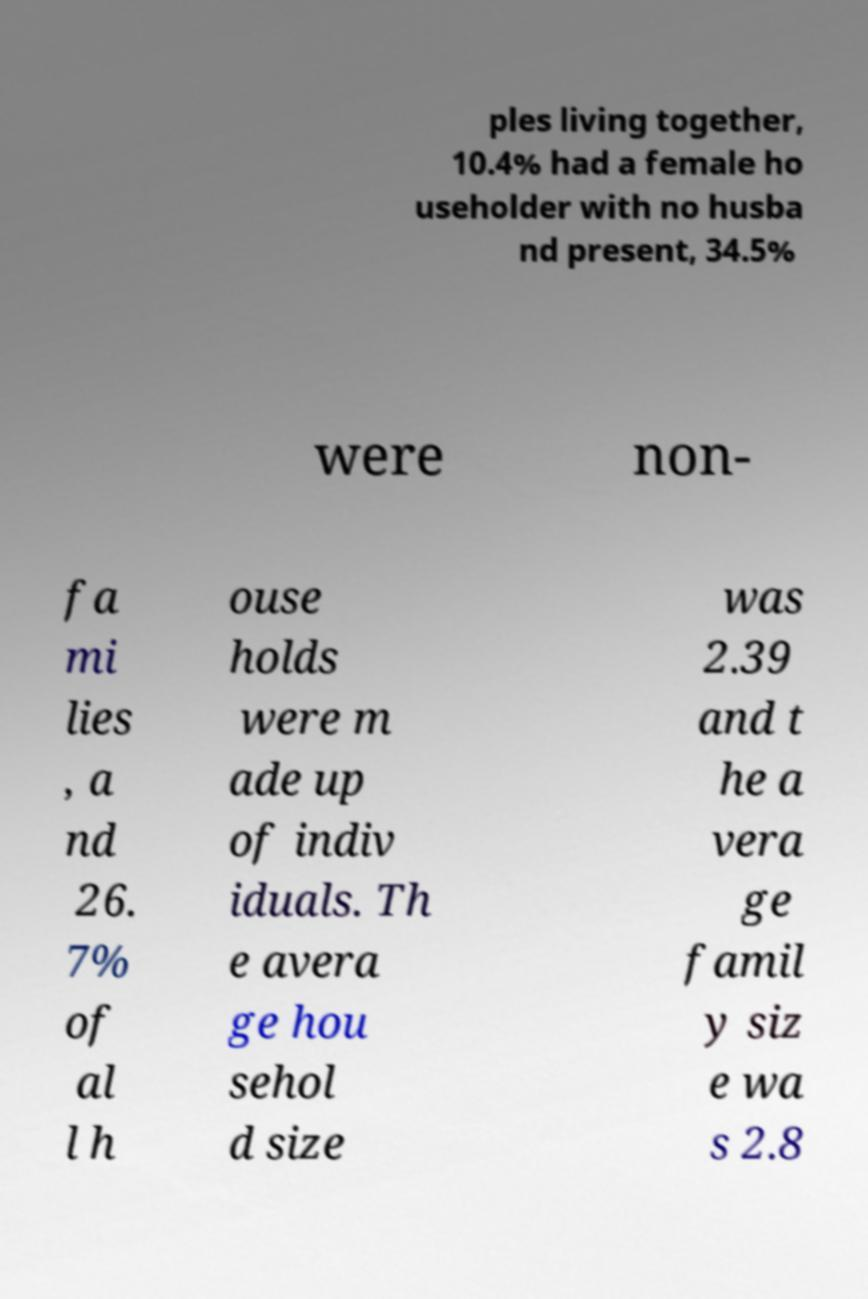Please identify and transcribe the text found in this image. ples living together, 10.4% had a female ho useholder with no husba nd present, 34.5% were non- fa mi lies , a nd 26. 7% of al l h ouse holds were m ade up of indiv iduals. Th e avera ge hou sehol d size was 2.39 and t he a vera ge famil y siz e wa s 2.8 